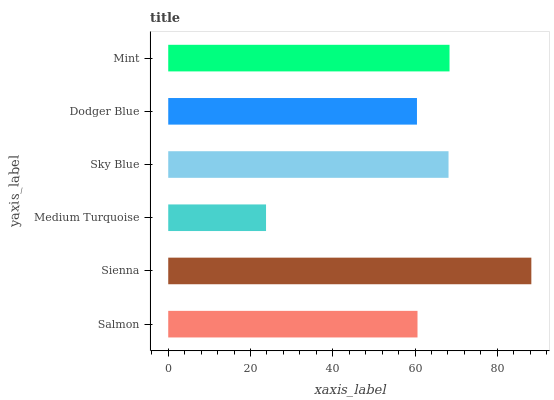Is Medium Turquoise the minimum?
Answer yes or no. Yes. Is Sienna the maximum?
Answer yes or no. Yes. Is Sienna the minimum?
Answer yes or no. No. Is Medium Turquoise the maximum?
Answer yes or no. No. Is Sienna greater than Medium Turquoise?
Answer yes or no. Yes. Is Medium Turquoise less than Sienna?
Answer yes or no. Yes. Is Medium Turquoise greater than Sienna?
Answer yes or no. No. Is Sienna less than Medium Turquoise?
Answer yes or no. No. Is Sky Blue the high median?
Answer yes or no. Yes. Is Salmon the low median?
Answer yes or no. Yes. Is Sienna the high median?
Answer yes or no. No. Is Medium Turquoise the low median?
Answer yes or no. No. 